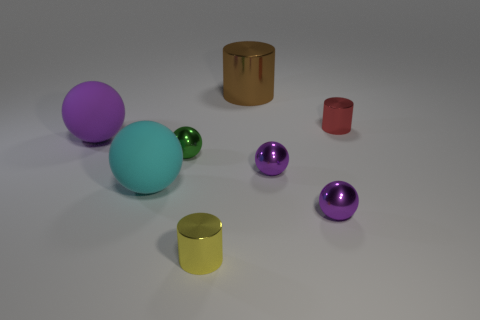How many other cylinders have the same material as the tiny yellow cylinder?
Your answer should be compact. 2. Do the yellow object and the object behind the red thing have the same material?
Offer a very short reply. Yes. How many things are either big objects in front of the large purple matte object or small purple metallic blocks?
Give a very brief answer. 1. How big is the cylinder that is in front of the purple sphere that is on the left side of the brown object that is left of the small red metal cylinder?
Give a very brief answer. Small. Is there anything else that has the same shape as the big cyan rubber thing?
Provide a succinct answer. Yes. There is a metal thing left of the cylinder left of the large brown metallic cylinder; how big is it?
Provide a short and direct response. Small. What number of big things are either red metallic cylinders or purple rubber things?
Ensure brevity in your answer.  1. Is the number of purple metal objects less than the number of red shiny objects?
Your answer should be compact. No. Is the number of tiny green metallic spheres greater than the number of small cyan cubes?
Offer a very short reply. Yes. What number of other things are there of the same color as the big metal object?
Offer a very short reply. 0. 